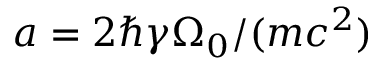Convert formula to latex. <formula><loc_0><loc_0><loc_500><loc_500>a = 2 \hbar { \gamma } \Omega _ { 0 } / ( m c ^ { 2 } )</formula> 